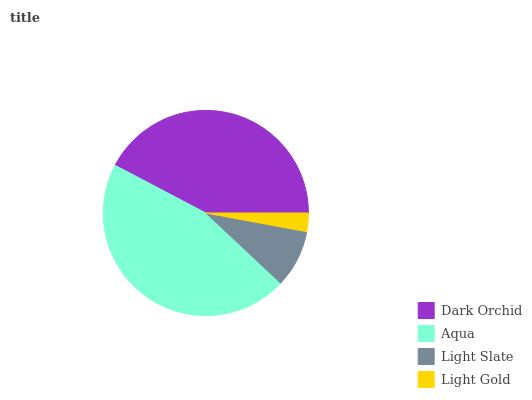Is Light Gold the minimum?
Answer yes or no. Yes. Is Aqua the maximum?
Answer yes or no. Yes. Is Light Slate the minimum?
Answer yes or no. No. Is Light Slate the maximum?
Answer yes or no. No. Is Aqua greater than Light Slate?
Answer yes or no. Yes. Is Light Slate less than Aqua?
Answer yes or no. Yes. Is Light Slate greater than Aqua?
Answer yes or no. No. Is Aqua less than Light Slate?
Answer yes or no. No. Is Dark Orchid the high median?
Answer yes or no. Yes. Is Light Slate the low median?
Answer yes or no. Yes. Is Light Slate the high median?
Answer yes or no. No. Is Aqua the low median?
Answer yes or no. No. 